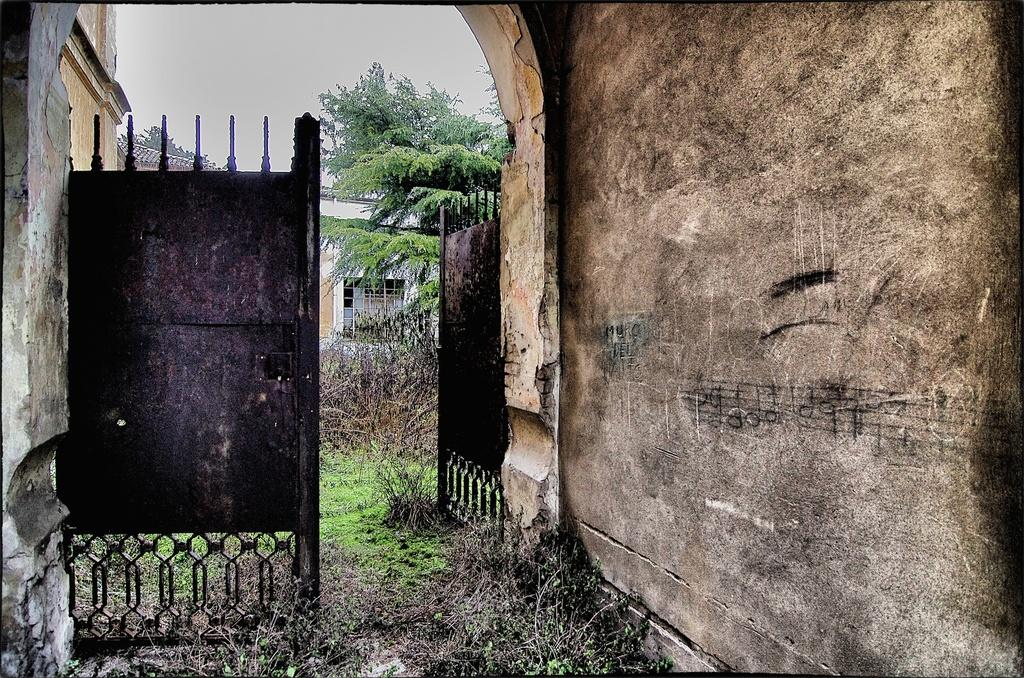What type of structure can be seen in the image? There is a gate and walls in the image. What type of vegetation is present in the image? There are plants, grass, and trees in the image. What type of building is visible in the image? There is a building with windows in the image. What is visible in the background of the image? The sky is visible in the image, and it appears to be cloudy. Can you tell me what type of watch is being sold in the shop in the image? There is no shop or watch present in the image. What type of ear is visible on the person in the image? There are no people or ears visible in the image. 